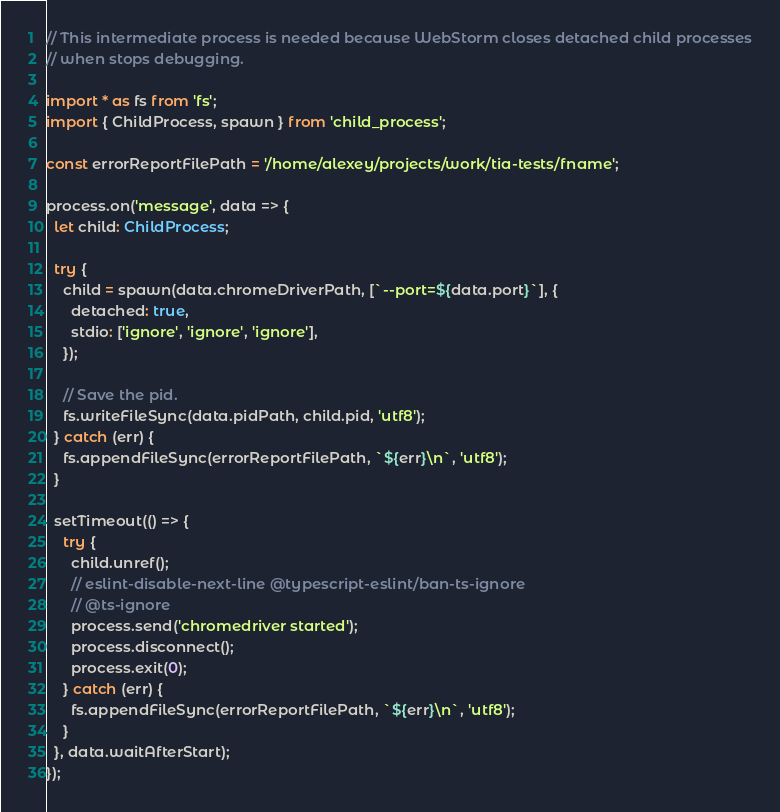Convert code to text. <code><loc_0><loc_0><loc_500><loc_500><_TypeScript_>

// This intermediate process is needed because WebStorm closes detached child processes
// when stops debugging.

import * as fs from 'fs';
import { ChildProcess, spawn } from 'child_process';

const errorReportFilePath = '/home/alexey/projects/work/tia-tests/fname';

process.on('message', data => {
  let child: ChildProcess;

  try {
    child = spawn(data.chromeDriverPath, [`--port=${data.port}`], {
      detached: true,
      stdio: ['ignore', 'ignore', 'ignore'],
    });

    // Save the pid.
    fs.writeFileSync(data.pidPath, child.pid, 'utf8');
  } catch (err) {
    fs.appendFileSync(errorReportFilePath, `${err}\n`, 'utf8');
  }

  setTimeout(() => {
    try {
      child.unref();
      // eslint-disable-next-line @typescript-eslint/ban-ts-ignore
      // @ts-ignore
      process.send('chromedriver started');
      process.disconnect();
      process.exit(0);
    } catch (err) {
      fs.appendFileSync(errorReportFilePath, `${err}\n`, 'utf8');
    }
  }, data.waitAfterStart);
});
</code> 